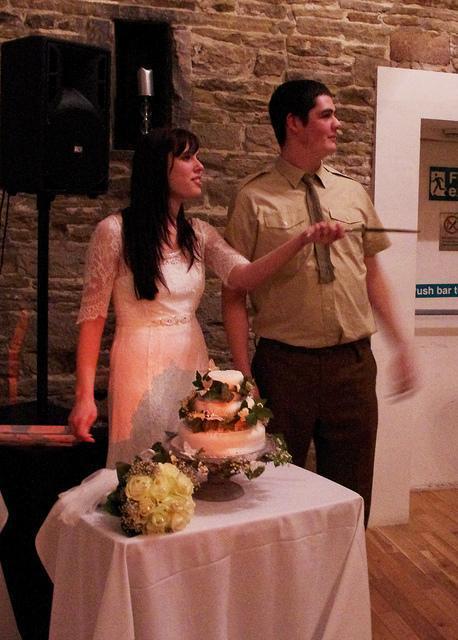How many layers does the cake have?
Give a very brief answer. 3. How many people in the shot?
Give a very brief answer. 2. How many people are there?
Give a very brief answer. 2. 